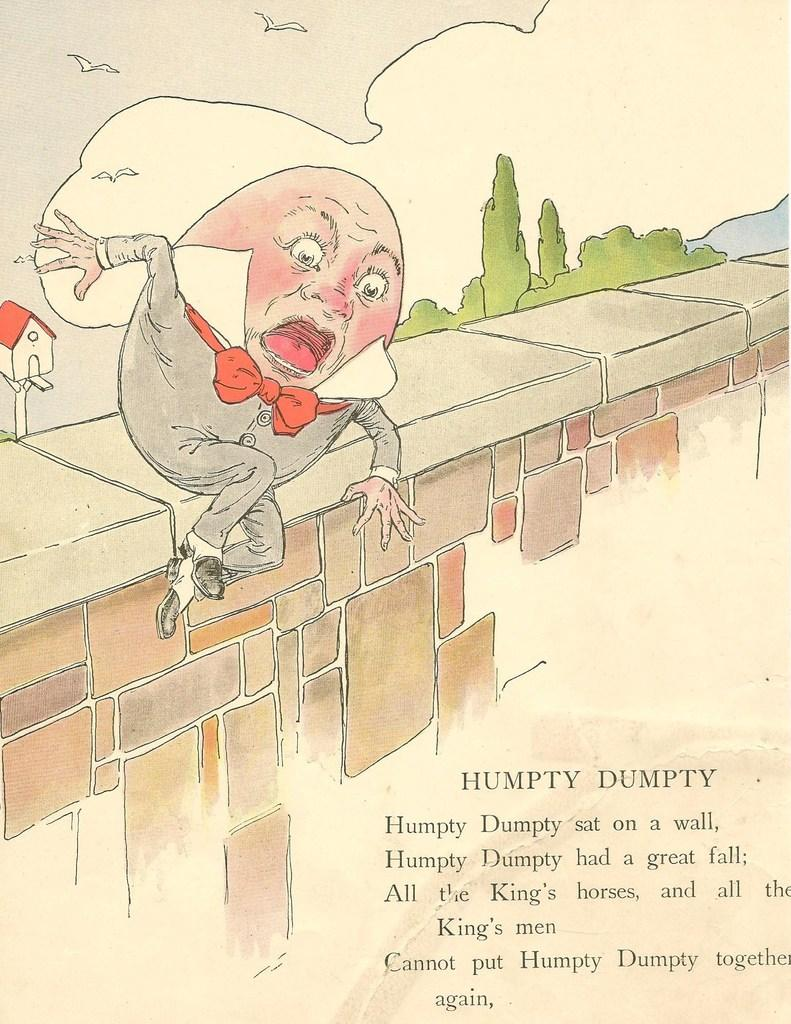What type of image is this? The image is animated. What is the person in the image doing? The person is jumping in the image. Are there any words or phrases in the image? Yes, there is text present in the image. What type of vegetation can be seen in the image? There are plants and trees in the image. What type of structure is visible in the image? There is a house in the image. How many tickets are visible in the image? There are no tickets present in the image. What type of addition can be seen in the image? There is no addition visible in the image; it is a static scene with a jumping person, text, plants, trees, and a house. Is the image set in space? No, the image is not set in space; it features a jumping person, text, plants, trees, and a house on Earth. 